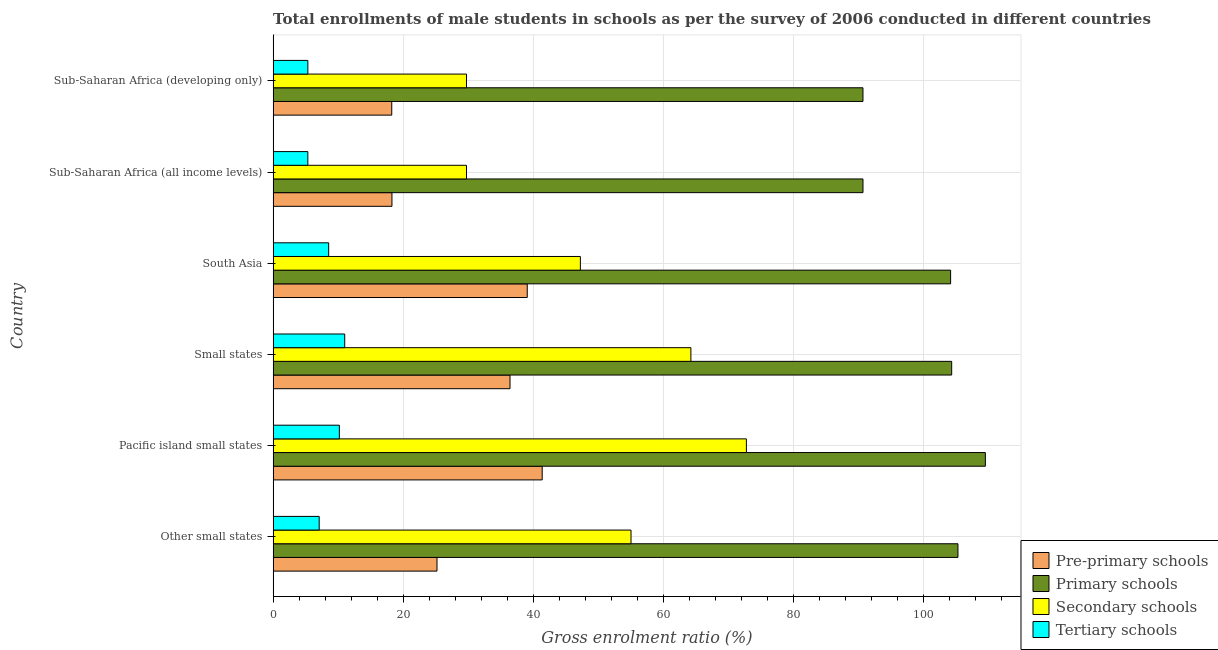How many different coloured bars are there?
Provide a succinct answer. 4. Are the number of bars per tick equal to the number of legend labels?
Your answer should be very brief. Yes. How many bars are there on the 1st tick from the top?
Provide a succinct answer. 4. What is the label of the 1st group of bars from the top?
Make the answer very short. Sub-Saharan Africa (developing only). What is the gross enrolment ratio(male) in pre-primary schools in South Asia?
Your response must be concise. 39.09. Across all countries, what is the maximum gross enrolment ratio(male) in secondary schools?
Make the answer very short. 72.81. Across all countries, what is the minimum gross enrolment ratio(male) in pre-primary schools?
Your answer should be compact. 18.25. In which country was the gross enrolment ratio(male) in pre-primary schools maximum?
Keep it short and to the point. Pacific island small states. In which country was the gross enrolment ratio(male) in pre-primary schools minimum?
Keep it short and to the point. Sub-Saharan Africa (developing only). What is the total gross enrolment ratio(male) in primary schools in the graph?
Your response must be concise. 605. What is the difference between the gross enrolment ratio(male) in secondary schools in Other small states and that in Pacific island small states?
Your response must be concise. -17.75. What is the difference between the gross enrolment ratio(male) in pre-primary schools in Small states and the gross enrolment ratio(male) in secondary schools in Sub-Saharan Africa (developing only)?
Offer a very short reply. 6.7. What is the average gross enrolment ratio(male) in secondary schools per country?
Your answer should be compact. 49.81. What is the difference between the gross enrolment ratio(male) in secondary schools and gross enrolment ratio(male) in pre-primary schools in Sub-Saharan Africa (all income levels)?
Keep it short and to the point. 11.47. In how many countries, is the gross enrolment ratio(male) in tertiary schools greater than 28 %?
Your answer should be very brief. 0. What is the ratio of the gross enrolment ratio(male) in secondary schools in South Asia to that in Sub-Saharan Africa (developing only)?
Give a very brief answer. 1.59. Is the gross enrolment ratio(male) in secondary schools in Other small states less than that in South Asia?
Your answer should be very brief. No. What is the difference between the highest and the second highest gross enrolment ratio(male) in secondary schools?
Provide a short and direct response. 8.54. What is the difference between the highest and the lowest gross enrolment ratio(male) in primary schools?
Ensure brevity in your answer.  18.83. In how many countries, is the gross enrolment ratio(male) in pre-primary schools greater than the average gross enrolment ratio(male) in pre-primary schools taken over all countries?
Keep it short and to the point. 3. Is the sum of the gross enrolment ratio(male) in primary schools in Sub-Saharan Africa (all income levels) and Sub-Saharan Africa (developing only) greater than the maximum gross enrolment ratio(male) in tertiary schools across all countries?
Provide a short and direct response. Yes. What does the 2nd bar from the top in South Asia represents?
Ensure brevity in your answer.  Secondary schools. What does the 3rd bar from the bottom in South Asia represents?
Offer a very short reply. Secondary schools. Is it the case that in every country, the sum of the gross enrolment ratio(male) in pre-primary schools and gross enrolment ratio(male) in primary schools is greater than the gross enrolment ratio(male) in secondary schools?
Offer a very short reply. Yes. Are all the bars in the graph horizontal?
Provide a short and direct response. Yes. How many countries are there in the graph?
Offer a terse response. 6. Are the values on the major ticks of X-axis written in scientific E-notation?
Offer a very short reply. No. Does the graph contain grids?
Make the answer very short. Yes. Where does the legend appear in the graph?
Your response must be concise. Bottom right. How many legend labels are there?
Your answer should be very brief. 4. How are the legend labels stacked?
Your response must be concise. Vertical. What is the title of the graph?
Offer a very short reply. Total enrollments of male students in schools as per the survey of 2006 conducted in different countries. Does "Trade" appear as one of the legend labels in the graph?
Give a very brief answer. No. What is the label or title of the X-axis?
Your answer should be compact. Gross enrolment ratio (%). What is the label or title of the Y-axis?
Keep it short and to the point. Country. What is the Gross enrolment ratio (%) in Pre-primary schools in Other small states?
Your answer should be very brief. 25.21. What is the Gross enrolment ratio (%) in Primary schools in Other small states?
Ensure brevity in your answer.  105.35. What is the Gross enrolment ratio (%) in Secondary schools in Other small states?
Offer a terse response. 55.06. What is the Gross enrolment ratio (%) in Tertiary schools in Other small states?
Your response must be concise. 7.09. What is the Gross enrolment ratio (%) in Pre-primary schools in Pacific island small states?
Your answer should be very brief. 41.39. What is the Gross enrolment ratio (%) in Primary schools in Pacific island small states?
Your answer should be compact. 109.57. What is the Gross enrolment ratio (%) of Secondary schools in Pacific island small states?
Your response must be concise. 72.81. What is the Gross enrolment ratio (%) of Tertiary schools in Pacific island small states?
Ensure brevity in your answer.  10.19. What is the Gross enrolment ratio (%) in Pre-primary schools in Small states?
Your answer should be very brief. 36.44. What is the Gross enrolment ratio (%) of Primary schools in Small states?
Offer a terse response. 104.39. What is the Gross enrolment ratio (%) of Secondary schools in Small states?
Your response must be concise. 64.27. What is the Gross enrolment ratio (%) of Tertiary schools in Small states?
Give a very brief answer. 11.01. What is the Gross enrolment ratio (%) of Pre-primary schools in South Asia?
Ensure brevity in your answer.  39.09. What is the Gross enrolment ratio (%) in Primary schools in South Asia?
Make the answer very short. 104.22. What is the Gross enrolment ratio (%) of Secondary schools in South Asia?
Keep it short and to the point. 47.26. What is the Gross enrolment ratio (%) of Tertiary schools in South Asia?
Ensure brevity in your answer.  8.55. What is the Gross enrolment ratio (%) of Pre-primary schools in Sub-Saharan Africa (all income levels)?
Your answer should be compact. 18.28. What is the Gross enrolment ratio (%) of Primary schools in Sub-Saharan Africa (all income levels)?
Offer a very short reply. 90.74. What is the Gross enrolment ratio (%) in Secondary schools in Sub-Saharan Africa (all income levels)?
Make the answer very short. 29.75. What is the Gross enrolment ratio (%) of Tertiary schools in Sub-Saharan Africa (all income levels)?
Make the answer very short. 5.34. What is the Gross enrolment ratio (%) in Pre-primary schools in Sub-Saharan Africa (developing only)?
Your answer should be very brief. 18.25. What is the Gross enrolment ratio (%) in Primary schools in Sub-Saharan Africa (developing only)?
Offer a very short reply. 90.74. What is the Gross enrolment ratio (%) in Secondary schools in Sub-Saharan Africa (developing only)?
Provide a succinct answer. 29.75. What is the Gross enrolment ratio (%) in Tertiary schools in Sub-Saharan Africa (developing only)?
Offer a very short reply. 5.34. Across all countries, what is the maximum Gross enrolment ratio (%) in Pre-primary schools?
Your response must be concise. 41.39. Across all countries, what is the maximum Gross enrolment ratio (%) in Primary schools?
Ensure brevity in your answer.  109.57. Across all countries, what is the maximum Gross enrolment ratio (%) in Secondary schools?
Your response must be concise. 72.81. Across all countries, what is the maximum Gross enrolment ratio (%) in Tertiary schools?
Keep it short and to the point. 11.01. Across all countries, what is the minimum Gross enrolment ratio (%) of Pre-primary schools?
Give a very brief answer. 18.25. Across all countries, what is the minimum Gross enrolment ratio (%) in Primary schools?
Provide a succinct answer. 90.74. Across all countries, what is the minimum Gross enrolment ratio (%) in Secondary schools?
Ensure brevity in your answer.  29.75. Across all countries, what is the minimum Gross enrolment ratio (%) of Tertiary schools?
Your answer should be compact. 5.34. What is the total Gross enrolment ratio (%) in Pre-primary schools in the graph?
Provide a short and direct response. 178.66. What is the total Gross enrolment ratio (%) of Primary schools in the graph?
Your answer should be compact. 605. What is the total Gross enrolment ratio (%) in Secondary schools in the graph?
Offer a terse response. 298.89. What is the total Gross enrolment ratio (%) in Tertiary schools in the graph?
Ensure brevity in your answer.  47.52. What is the difference between the Gross enrolment ratio (%) in Pre-primary schools in Other small states and that in Pacific island small states?
Provide a short and direct response. -16.18. What is the difference between the Gross enrolment ratio (%) of Primary schools in Other small states and that in Pacific island small states?
Your response must be concise. -4.22. What is the difference between the Gross enrolment ratio (%) of Secondary schools in Other small states and that in Pacific island small states?
Make the answer very short. -17.75. What is the difference between the Gross enrolment ratio (%) in Tertiary schools in Other small states and that in Pacific island small states?
Make the answer very short. -3.1. What is the difference between the Gross enrolment ratio (%) of Pre-primary schools in Other small states and that in Small states?
Your answer should be very brief. -11.23. What is the difference between the Gross enrolment ratio (%) of Secondary schools in Other small states and that in Small states?
Your response must be concise. -9.21. What is the difference between the Gross enrolment ratio (%) of Tertiary schools in Other small states and that in Small states?
Your response must be concise. -3.93. What is the difference between the Gross enrolment ratio (%) of Pre-primary schools in Other small states and that in South Asia?
Your answer should be very brief. -13.88. What is the difference between the Gross enrolment ratio (%) in Primary schools in Other small states and that in South Asia?
Offer a terse response. 1.13. What is the difference between the Gross enrolment ratio (%) of Secondary schools in Other small states and that in South Asia?
Ensure brevity in your answer.  7.79. What is the difference between the Gross enrolment ratio (%) of Tertiary schools in Other small states and that in South Asia?
Provide a succinct answer. -1.46. What is the difference between the Gross enrolment ratio (%) in Pre-primary schools in Other small states and that in Sub-Saharan Africa (all income levels)?
Make the answer very short. 6.93. What is the difference between the Gross enrolment ratio (%) in Primary schools in Other small states and that in Sub-Saharan Africa (all income levels)?
Give a very brief answer. 14.61. What is the difference between the Gross enrolment ratio (%) of Secondary schools in Other small states and that in Sub-Saharan Africa (all income levels)?
Your answer should be very brief. 25.31. What is the difference between the Gross enrolment ratio (%) of Tertiary schools in Other small states and that in Sub-Saharan Africa (all income levels)?
Your answer should be very brief. 1.75. What is the difference between the Gross enrolment ratio (%) in Pre-primary schools in Other small states and that in Sub-Saharan Africa (developing only)?
Your answer should be very brief. 6.96. What is the difference between the Gross enrolment ratio (%) of Primary schools in Other small states and that in Sub-Saharan Africa (developing only)?
Your answer should be compact. 14.61. What is the difference between the Gross enrolment ratio (%) in Secondary schools in Other small states and that in Sub-Saharan Africa (developing only)?
Your answer should be compact. 25.31. What is the difference between the Gross enrolment ratio (%) in Tertiary schools in Other small states and that in Sub-Saharan Africa (developing only)?
Provide a short and direct response. 1.74. What is the difference between the Gross enrolment ratio (%) of Pre-primary schools in Pacific island small states and that in Small states?
Make the answer very short. 4.95. What is the difference between the Gross enrolment ratio (%) of Primary schools in Pacific island small states and that in Small states?
Provide a short and direct response. 5.18. What is the difference between the Gross enrolment ratio (%) of Secondary schools in Pacific island small states and that in Small states?
Offer a very short reply. 8.54. What is the difference between the Gross enrolment ratio (%) in Tertiary schools in Pacific island small states and that in Small states?
Your answer should be very brief. -0.83. What is the difference between the Gross enrolment ratio (%) in Pre-primary schools in Pacific island small states and that in South Asia?
Ensure brevity in your answer.  2.3. What is the difference between the Gross enrolment ratio (%) of Primary schools in Pacific island small states and that in South Asia?
Give a very brief answer. 5.35. What is the difference between the Gross enrolment ratio (%) of Secondary schools in Pacific island small states and that in South Asia?
Ensure brevity in your answer.  25.54. What is the difference between the Gross enrolment ratio (%) of Tertiary schools in Pacific island small states and that in South Asia?
Keep it short and to the point. 1.64. What is the difference between the Gross enrolment ratio (%) in Pre-primary schools in Pacific island small states and that in Sub-Saharan Africa (all income levels)?
Offer a very short reply. 23.11. What is the difference between the Gross enrolment ratio (%) in Primary schools in Pacific island small states and that in Sub-Saharan Africa (all income levels)?
Provide a short and direct response. 18.83. What is the difference between the Gross enrolment ratio (%) of Secondary schools in Pacific island small states and that in Sub-Saharan Africa (all income levels)?
Provide a succinct answer. 43.06. What is the difference between the Gross enrolment ratio (%) in Tertiary schools in Pacific island small states and that in Sub-Saharan Africa (all income levels)?
Keep it short and to the point. 4.85. What is the difference between the Gross enrolment ratio (%) of Pre-primary schools in Pacific island small states and that in Sub-Saharan Africa (developing only)?
Provide a succinct answer. 23.14. What is the difference between the Gross enrolment ratio (%) of Primary schools in Pacific island small states and that in Sub-Saharan Africa (developing only)?
Provide a short and direct response. 18.83. What is the difference between the Gross enrolment ratio (%) in Secondary schools in Pacific island small states and that in Sub-Saharan Africa (developing only)?
Give a very brief answer. 43.06. What is the difference between the Gross enrolment ratio (%) of Tertiary schools in Pacific island small states and that in Sub-Saharan Africa (developing only)?
Make the answer very short. 4.84. What is the difference between the Gross enrolment ratio (%) in Pre-primary schools in Small states and that in South Asia?
Provide a short and direct response. -2.65. What is the difference between the Gross enrolment ratio (%) in Primary schools in Small states and that in South Asia?
Ensure brevity in your answer.  0.16. What is the difference between the Gross enrolment ratio (%) of Secondary schools in Small states and that in South Asia?
Your answer should be very brief. 17. What is the difference between the Gross enrolment ratio (%) of Tertiary schools in Small states and that in South Asia?
Offer a very short reply. 2.47. What is the difference between the Gross enrolment ratio (%) of Pre-primary schools in Small states and that in Sub-Saharan Africa (all income levels)?
Offer a very short reply. 18.16. What is the difference between the Gross enrolment ratio (%) of Primary schools in Small states and that in Sub-Saharan Africa (all income levels)?
Provide a short and direct response. 13.65. What is the difference between the Gross enrolment ratio (%) of Secondary schools in Small states and that in Sub-Saharan Africa (all income levels)?
Offer a terse response. 34.52. What is the difference between the Gross enrolment ratio (%) of Tertiary schools in Small states and that in Sub-Saharan Africa (all income levels)?
Ensure brevity in your answer.  5.67. What is the difference between the Gross enrolment ratio (%) of Pre-primary schools in Small states and that in Sub-Saharan Africa (developing only)?
Give a very brief answer. 18.2. What is the difference between the Gross enrolment ratio (%) of Primary schools in Small states and that in Sub-Saharan Africa (developing only)?
Offer a very short reply. 13.65. What is the difference between the Gross enrolment ratio (%) in Secondary schools in Small states and that in Sub-Saharan Africa (developing only)?
Provide a short and direct response. 34.52. What is the difference between the Gross enrolment ratio (%) of Tertiary schools in Small states and that in Sub-Saharan Africa (developing only)?
Provide a succinct answer. 5.67. What is the difference between the Gross enrolment ratio (%) of Pre-primary schools in South Asia and that in Sub-Saharan Africa (all income levels)?
Your response must be concise. 20.81. What is the difference between the Gross enrolment ratio (%) in Primary schools in South Asia and that in Sub-Saharan Africa (all income levels)?
Make the answer very short. 13.48. What is the difference between the Gross enrolment ratio (%) of Secondary schools in South Asia and that in Sub-Saharan Africa (all income levels)?
Keep it short and to the point. 17.52. What is the difference between the Gross enrolment ratio (%) in Tertiary schools in South Asia and that in Sub-Saharan Africa (all income levels)?
Ensure brevity in your answer.  3.2. What is the difference between the Gross enrolment ratio (%) of Pre-primary schools in South Asia and that in Sub-Saharan Africa (developing only)?
Provide a short and direct response. 20.85. What is the difference between the Gross enrolment ratio (%) of Primary schools in South Asia and that in Sub-Saharan Africa (developing only)?
Keep it short and to the point. 13.48. What is the difference between the Gross enrolment ratio (%) of Secondary schools in South Asia and that in Sub-Saharan Africa (developing only)?
Give a very brief answer. 17.52. What is the difference between the Gross enrolment ratio (%) in Tertiary schools in South Asia and that in Sub-Saharan Africa (developing only)?
Make the answer very short. 3.2. What is the difference between the Gross enrolment ratio (%) in Pre-primary schools in Sub-Saharan Africa (all income levels) and that in Sub-Saharan Africa (developing only)?
Provide a short and direct response. 0.03. What is the difference between the Gross enrolment ratio (%) of Primary schools in Sub-Saharan Africa (all income levels) and that in Sub-Saharan Africa (developing only)?
Keep it short and to the point. 0. What is the difference between the Gross enrolment ratio (%) in Secondary schools in Sub-Saharan Africa (all income levels) and that in Sub-Saharan Africa (developing only)?
Offer a terse response. -0. What is the difference between the Gross enrolment ratio (%) of Tertiary schools in Sub-Saharan Africa (all income levels) and that in Sub-Saharan Africa (developing only)?
Offer a very short reply. -0. What is the difference between the Gross enrolment ratio (%) of Pre-primary schools in Other small states and the Gross enrolment ratio (%) of Primary schools in Pacific island small states?
Give a very brief answer. -84.36. What is the difference between the Gross enrolment ratio (%) of Pre-primary schools in Other small states and the Gross enrolment ratio (%) of Secondary schools in Pacific island small states?
Provide a succinct answer. -47.6. What is the difference between the Gross enrolment ratio (%) of Pre-primary schools in Other small states and the Gross enrolment ratio (%) of Tertiary schools in Pacific island small states?
Provide a succinct answer. 15.02. What is the difference between the Gross enrolment ratio (%) of Primary schools in Other small states and the Gross enrolment ratio (%) of Secondary schools in Pacific island small states?
Your answer should be very brief. 32.54. What is the difference between the Gross enrolment ratio (%) in Primary schools in Other small states and the Gross enrolment ratio (%) in Tertiary schools in Pacific island small states?
Make the answer very short. 95.16. What is the difference between the Gross enrolment ratio (%) in Secondary schools in Other small states and the Gross enrolment ratio (%) in Tertiary schools in Pacific island small states?
Provide a short and direct response. 44.87. What is the difference between the Gross enrolment ratio (%) of Pre-primary schools in Other small states and the Gross enrolment ratio (%) of Primary schools in Small states?
Ensure brevity in your answer.  -79.18. What is the difference between the Gross enrolment ratio (%) in Pre-primary schools in Other small states and the Gross enrolment ratio (%) in Secondary schools in Small states?
Offer a very short reply. -39.06. What is the difference between the Gross enrolment ratio (%) in Pre-primary schools in Other small states and the Gross enrolment ratio (%) in Tertiary schools in Small states?
Give a very brief answer. 14.2. What is the difference between the Gross enrolment ratio (%) in Primary schools in Other small states and the Gross enrolment ratio (%) in Secondary schools in Small states?
Provide a succinct answer. 41.08. What is the difference between the Gross enrolment ratio (%) in Primary schools in Other small states and the Gross enrolment ratio (%) in Tertiary schools in Small states?
Give a very brief answer. 94.34. What is the difference between the Gross enrolment ratio (%) of Secondary schools in Other small states and the Gross enrolment ratio (%) of Tertiary schools in Small states?
Your answer should be compact. 44.04. What is the difference between the Gross enrolment ratio (%) in Pre-primary schools in Other small states and the Gross enrolment ratio (%) in Primary schools in South Asia?
Give a very brief answer. -79.01. What is the difference between the Gross enrolment ratio (%) in Pre-primary schools in Other small states and the Gross enrolment ratio (%) in Secondary schools in South Asia?
Provide a short and direct response. -22.06. What is the difference between the Gross enrolment ratio (%) in Pre-primary schools in Other small states and the Gross enrolment ratio (%) in Tertiary schools in South Asia?
Ensure brevity in your answer.  16.66. What is the difference between the Gross enrolment ratio (%) of Primary schools in Other small states and the Gross enrolment ratio (%) of Secondary schools in South Asia?
Provide a succinct answer. 58.09. What is the difference between the Gross enrolment ratio (%) in Primary schools in Other small states and the Gross enrolment ratio (%) in Tertiary schools in South Asia?
Provide a succinct answer. 96.8. What is the difference between the Gross enrolment ratio (%) in Secondary schools in Other small states and the Gross enrolment ratio (%) in Tertiary schools in South Asia?
Ensure brevity in your answer.  46.51. What is the difference between the Gross enrolment ratio (%) in Pre-primary schools in Other small states and the Gross enrolment ratio (%) in Primary schools in Sub-Saharan Africa (all income levels)?
Give a very brief answer. -65.53. What is the difference between the Gross enrolment ratio (%) of Pre-primary schools in Other small states and the Gross enrolment ratio (%) of Secondary schools in Sub-Saharan Africa (all income levels)?
Your response must be concise. -4.54. What is the difference between the Gross enrolment ratio (%) of Pre-primary schools in Other small states and the Gross enrolment ratio (%) of Tertiary schools in Sub-Saharan Africa (all income levels)?
Offer a terse response. 19.87. What is the difference between the Gross enrolment ratio (%) of Primary schools in Other small states and the Gross enrolment ratio (%) of Secondary schools in Sub-Saharan Africa (all income levels)?
Give a very brief answer. 75.6. What is the difference between the Gross enrolment ratio (%) in Primary schools in Other small states and the Gross enrolment ratio (%) in Tertiary schools in Sub-Saharan Africa (all income levels)?
Make the answer very short. 100.01. What is the difference between the Gross enrolment ratio (%) of Secondary schools in Other small states and the Gross enrolment ratio (%) of Tertiary schools in Sub-Saharan Africa (all income levels)?
Offer a terse response. 49.72. What is the difference between the Gross enrolment ratio (%) in Pre-primary schools in Other small states and the Gross enrolment ratio (%) in Primary schools in Sub-Saharan Africa (developing only)?
Your response must be concise. -65.53. What is the difference between the Gross enrolment ratio (%) in Pre-primary schools in Other small states and the Gross enrolment ratio (%) in Secondary schools in Sub-Saharan Africa (developing only)?
Offer a very short reply. -4.54. What is the difference between the Gross enrolment ratio (%) of Pre-primary schools in Other small states and the Gross enrolment ratio (%) of Tertiary schools in Sub-Saharan Africa (developing only)?
Make the answer very short. 19.86. What is the difference between the Gross enrolment ratio (%) of Primary schools in Other small states and the Gross enrolment ratio (%) of Secondary schools in Sub-Saharan Africa (developing only)?
Give a very brief answer. 75.6. What is the difference between the Gross enrolment ratio (%) in Primary schools in Other small states and the Gross enrolment ratio (%) in Tertiary schools in Sub-Saharan Africa (developing only)?
Your answer should be compact. 100.01. What is the difference between the Gross enrolment ratio (%) of Secondary schools in Other small states and the Gross enrolment ratio (%) of Tertiary schools in Sub-Saharan Africa (developing only)?
Give a very brief answer. 49.71. What is the difference between the Gross enrolment ratio (%) in Pre-primary schools in Pacific island small states and the Gross enrolment ratio (%) in Primary schools in Small states?
Your answer should be very brief. -62.99. What is the difference between the Gross enrolment ratio (%) of Pre-primary schools in Pacific island small states and the Gross enrolment ratio (%) of Secondary schools in Small states?
Your response must be concise. -22.87. What is the difference between the Gross enrolment ratio (%) in Pre-primary schools in Pacific island small states and the Gross enrolment ratio (%) in Tertiary schools in Small states?
Make the answer very short. 30.38. What is the difference between the Gross enrolment ratio (%) of Primary schools in Pacific island small states and the Gross enrolment ratio (%) of Secondary schools in Small states?
Your answer should be very brief. 45.3. What is the difference between the Gross enrolment ratio (%) of Primary schools in Pacific island small states and the Gross enrolment ratio (%) of Tertiary schools in Small states?
Give a very brief answer. 98.55. What is the difference between the Gross enrolment ratio (%) of Secondary schools in Pacific island small states and the Gross enrolment ratio (%) of Tertiary schools in Small states?
Offer a terse response. 61.79. What is the difference between the Gross enrolment ratio (%) in Pre-primary schools in Pacific island small states and the Gross enrolment ratio (%) in Primary schools in South Asia?
Your response must be concise. -62.83. What is the difference between the Gross enrolment ratio (%) in Pre-primary schools in Pacific island small states and the Gross enrolment ratio (%) in Secondary schools in South Asia?
Offer a very short reply. -5.87. What is the difference between the Gross enrolment ratio (%) of Pre-primary schools in Pacific island small states and the Gross enrolment ratio (%) of Tertiary schools in South Asia?
Offer a terse response. 32.85. What is the difference between the Gross enrolment ratio (%) of Primary schools in Pacific island small states and the Gross enrolment ratio (%) of Secondary schools in South Asia?
Your response must be concise. 62.3. What is the difference between the Gross enrolment ratio (%) of Primary schools in Pacific island small states and the Gross enrolment ratio (%) of Tertiary schools in South Asia?
Your answer should be compact. 101.02. What is the difference between the Gross enrolment ratio (%) of Secondary schools in Pacific island small states and the Gross enrolment ratio (%) of Tertiary schools in South Asia?
Keep it short and to the point. 64.26. What is the difference between the Gross enrolment ratio (%) of Pre-primary schools in Pacific island small states and the Gross enrolment ratio (%) of Primary schools in Sub-Saharan Africa (all income levels)?
Offer a terse response. -49.35. What is the difference between the Gross enrolment ratio (%) of Pre-primary schools in Pacific island small states and the Gross enrolment ratio (%) of Secondary schools in Sub-Saharan Africa (all income levels)?
Ensure brevity in your answer.  11.65. What is the difference between the Gross enrolment ratio (%) of Pre-primary schools in Pacific island small states and the Gross enrolment ratio (%) of Tertiary schools in Sub-Saharan Africa (all income levels)?
Your response must be concise. 36.05. What is the difference between the Gross enrolment ratio (%) of Primary schools in Pacific island small states and the Gross enrolment ratio (%) of Secondary schools in Sub-Saharan Africa (all income levels)?
Make the answer very short. 79.82. What is the difference between the Gross enrolment ratio (%) in Primary schools in Pacific island small states and the Gross enrolment ratio (%) in Tertiary schools in Sub-Saharan Africa (all income levels)?
Keep it short and to the point. 104.22. What is the difference between the Gross enrolment ratio (%) in Secondary schools in Pacific island small states and the Gross enrolment ratio (%) in Tertiary schools in Sub-Saharan Africa (all income levels)?
Keep it short and to the point. 67.46. What is the difference between the Gross enrolment ratio (%) in Pre-primary schools in Pacific island small states and the Gross enrolment ratio (%) in Primary schools in Sub-Saharan Africa (developing only)?
Your response must be concise. -49.35. What is the difference between the Gross enrolment ratio (%) in Pre-primary schools in Pacific island small states and the Gross enrolment ratio (%) in Secondary schools in Sub-Saharan Africa (developing only)?
Keep it short and to the point. 11.64. What is the difference between the Gross enrolment ratio (%) in Pre-primary schools in Pacific island small states and the Gross enrolment ratio (%) in Tertiary schools in Sub-Saharan Africa (developing only)?
Offer a very short reply. 36.05. What is the difference between the Gross enrolment ratio (%) in Primary schools in Pacific island small states and the Gross enrolment ratio (%) in Secondary schools in Sub-Saharan Africa (developing only)?
Offer a terse response. 79.82. What is the difference between the Gross enrolment ratio (%) of Primary schools in Pacific island small states and the Gross enrolment ratio (%) of Tertiary schools in Sub-Saharan Africa (developing only)?
Keep it short and to the point. 104.22. What is the difference between the Gross enrolment ratio (%) in Secondary schools in Pacific island small states and the Gross enrolment ratio (%) in Tertiary schools in Sub-Saharan Africa (developing only)?
Your answer should be very brief. 67.46. What is the difference between the Gross enrolment ratio (%) of Pre-primary schools in Small states and the Gross enrolment ratio (%) of Primary schools in South Asia?
Provide a succinct answer. -67.78. What is the difference between the Gross enrolment ratio (%) in Pre-primary schools in Small states and the Gross enrolment ratio (%) in Secondary schools in South Asia?
Your response must be concise. -10.82. What is the difference between the Gross enrolment ratio (%) of Pre-primary schools in Small states and the Gross enrolment ratio (%) of Tertiary schools in South Asia?
Your answer should be very brief. 27.9. What is the difference between the Gross enrolment ratio (%) in Primary schools in Small states and the Gross enrolment ratio (%) in Secondary schools in South Asia?
Keep it short and to the point. 57.12. What is the difference between the Gross enrolment ratio (%) of Primary schools in Small states and the Gross enrolment ratio (%) of Tertiary schools in South Asia?
Your response must be concise. 95.84. What is the difference between the Gross enrolment ratio (%) of Secondary schools in Small states and the Gross enrolment ratio (%) of Tertiary schools in South Asia?
Provide a succinct answer. 55.72. What is the difference between the Gross enrolment ratio (%) of Pre-primary schools in Small states and the Gross enrolment ratio (%) of Primary schools in Sub-Saharan Africa (all income levels)?
Make the answer very short. -54.3. What is the difference between the Gross enrolment ratio (%) in Pre-primary schools in Small states and the Gross enrolment ratio (%) in Secondary schools in Sub-Saharan Africa (all income levels)?
Make the answer very short. 6.7. What is the difference between the Gross enrolment ratio (%) in Pre-primary schools in Small states and the Gross enrolment ratio (%) in Tertiary schools in Sub-Saharan Africa (all income levels)?
Ensure brevity in your answer.  31.1. What is the difference between the Gross enrolment ratio (%) of Primary schools in Small states and the Gross enrolment ratio (%) of Secondary schools in Sub-Saharan Africa (all income levels)?
Your answer should be very brief. 74.64. What is the difference between the Gross enrolment ratio (%) in Primary schools in Small states and the Gross enrolment ratio (%) in Tertiary schools in Sub-Saharan Africa (all income levels)?
Keep it short and to the point. 99.04. What is the difference between the Gross enrolment ratio (%) in Secondary schools in Small states and the Gross enrolment ratio (%) in Tertiary schools in Sub-Saharan Africa (all income levels)?
Keep it short and to the point. 58.93. What is the difference between the Gross enrolment ratio (%) in Pre-primary schools in Small states and the Gross enrolment ratio (%) in Primary schools in Sub-Saharan Africa (developing only)?
Offer a very short reply. -54.29. What is the difference between the Gross enrolment ratio (%) of Pre-primary schools in Small states and the Gross enrolment ratio (%) of Secondary schools in Sub-Saharan Africa (developing only)?
Your response must be concise. 6.7. What is the difference between the Gross enrolment ratio (%) in Pre-primary schools in Small states and the Gross enrolment ratio (%) in Tertiary schools in Sub-Saharan Africa (developing only)?
Give a very brief answer. 31.1. What is the difference between the Gross enrolment ratio (%) in Primary schools in Small states and the Gross enrolment ratio (%) in Secondary schools in Sub-Saharan Africa (developing only)?
Provide a short and direct response. 74.64. What is the difference between the Gross enrolment ratio (%) of Primary schools in Small states and the Gross enrolment ratio (%) of Tertiary schools in Sub-Saharan Africa (developing only)?
Offer a very short reply. 99.04. What is the difference between the Gross enrolment ratio (%) of Secondary schools in Small states and the Gross enrolment ratio (%) of Tertiary schools in Sub-Saharan Africa (developing only)?
Make the answer very short. 58.92. What is the difference between the Gross enrolment ratio (%) in Pre-primary schools in South Asia and the Gross enrolment ratio (%) in Primary schools in Sub-Saharan Africa (all income levels)?
Your answer should be compact. -51.65. What is the difference between the Gross enrolment ratio (%) in Pre-primary schools in South Asia and the Gross enrolment ratio (%) in Secondary schools in Sub-Saharan Africa (all income levels)?
Your answer should be compact. 9.35. What is the difference between the Gross enrolment ratio (%) in Pre-primary schools in South Asia and the Gross enrolment ratio (%) in Tertiary schools in Sub-Saharan Africa (all income levels)?
Give a very brief answer. 33.75. What is the difference between the Gross enrolment ratio (%) in Primary schools in South Asia and the Gross enrolment ratio (%) in Secondary schools in Sub-Saharan Africa (all income levels)?
Make the answer very short. 74.47. What is the difference between the Gross enrolment ratio (%) in Primary schools in South Asia and the Gross enrolment ratio (%) in Tertiary schools in Sub-Saharan Africa (all income levels)?
Keep it short and to the point. 98.88. What is the difference between the Gross enrolment ratio (%) in Secondary schools in South Asia and the Gross enrolment ratio (%) in Tertiary schools in Sub-Saharan Africa (all income levels)?
Offer a very short reply. 41.92. What is the difference between the Gross enrolment ratio (%) of Pre-primary schools in South Asia and the Gross enrolment ratio (%) of Primary schools in Sub-Saharan Africa (developing only)?
Provide a short and direct response. -51.64. What is the difference between the Gross enrolment ratio (%) of Pre-primary schools in South Asia and the Gross enrolment ratio (%) of Secondary schools in Sub-Saharan Africa (developing only)?
Your answer should be very brief. 9.35. What is the difference between the Gross enrolment ratio (%) in Pre-primary schools in South Asia and the Gross enrolment ratio (%) in Tertiary schools in Sub-Saharan Africa (developing only)?
Your answer should be very brief. 33.75. What is the difference between the Gross enrolment ratio (%) in Primary schools in South Asia and the Gross enrolment ratio (%) in Secondary schools in Sub-Saharan Africa (developing only)?
Offer a very short reply. 74.47. What is the difference between the Gross enrolment ratio (%) of Primary schools in South Asia and the Gross enrolment ratio (%) of Tertiary schools in Sub-Saharan Africa (developing only)?
Make the answer very short. 98.88. What is the difference between the Gross enrolment ratio (%) in Secondary schools in South Asia and the Gross enrolment ratio (%) in Tertiary schools in Sub-Saharan Africa (developing only)?
Your answer should be compact. 41.92. What is the difference between the Gross enrolment ratio (%) of Pre-primary schools in Sub-Saharan Africa (all income levels) and the Gross enrolment ratio (%) of Primary schools in Sub-Saharan Africa (developing only)?
Provide a short and direct response. -72.46. What is the difference between the Gross enrolment ratio (%) of Pre-primary schools in Sub-Saharan Africa (all income levels) and the Gross enrolment ratio (%) of Secondary schools in Sub-Saharan Africa (developing only)?
Your answer should be compact. -11.47. What is the difference between the Gross enrolment ratio (%) in Pre-primary schools in Sub-Saharan Africa (all income levels) and the Gross enrolment ratio (%) in Tertiary schools in Sub-Saharan Africa (developing only)?
Your answer should be compact. 12.94. What is the difference between the Gross enrolment ratio (%) of Primary schools in Sub-Saharan Africa (all income levels) and the Gross enrolment ratio (%) of Secondary schools in Sub-Saharan Africa (developing only)?
Give a very brief answer. 60.99. What is the difference between the Gross enrolment ratio (%) in Primary schools in Sub-Saharan Africa (all income levels) and the Gross enrolment ratio (%) in Tertiary schools in Sub-Saharan Africa (developing only)?
Your answer should be compact. 85.4. What is the difference between the Gross enrolment ratio (%) in Secondary schools in Sub-Saharan Africa (all income levels) and the Gross enrolment ratio (%) in Tertiary schools in Sub-Saharan Africa (developing only)?
Keep it short and to the point. 24.4. What is the average Gross enrolment ratio (%) in Pre-primary schools per country?
Provide a short and direct response. 29.78. What is the average Gross enrolment ratio (%) in Primary schools per country?
Ensure brevity in your answer.  100.83. What is the average Gross enrolment ratio (%) of Secondary schools per country?
Make the answer very short. 49.81. What is the average Gross enrolment ratio (%) in Tertiary schools per country?
Provide a succinct answer. 7.92. What is the difference between the Gross enrolment ratio (%) in Pre-primary schools and Gross enrolment ratio (%) in Primary schools in Other small states?
Your answer should be compact. -80.14. What is the difference between the Gross enrolment ratio (%) of Pre-primary schools and Gross enrolment ratio (%) of Secondary schools in Other small states?
Offer a very short reply. -29.85. What is the difference between the Gross enrolment ratio (%) in Pre-primary schools and Gross enrolment ratio (%) in Tertiary schools in Other small states?
Your answer should be very brief. 18.12. What is the difference between the Gross enrolment ratio (%) of Primary schools and Gross enrolment ratio (%) of Secondary schools in Other small states?
Your answer should be compact. 50.29. What is the difference between the Gross enrolment ratio (%) of Primary schools and Gross enrolment ratio (%) of Tertiary schools in Other small states?
Ensure brevity in your answer.  98.26. What is the difference between the Gross enrolment ratio (%) of Secondary schools and Gross enrolment ratio (%) of Tertiary schools in Other small states?
Your answer should be very brief. 47.97. What is the difference between the Gross enrolment ratio (%) of Pre-primary schools and Gross enrolment ratio (%) of Primary schools in Pacific island small states?
Ensure brevity in your answer.  -68.17. What is the difference between the Gross enrolment ratio (%) in Pre-primary schools and Gross enrolment ratio (%) in Secondary schools in Pacific island small states?
Give a very brief answer. -31.41. What is the difference between the Gross enrolment ratio (%) of Pre-primary schools and Gross enrolment ratio (%) of Tertiary schools in Pacific island small states?
Make the answer very short. 31.21. What is the difference between the Gross enrolment ratio (%) in Primary schools and Gross enrolment ratio (%) in Secondary schools in Pacific island small states?
Provide a short and direct response. 36.76. What is the difference between the Gross enrolment ratio (%) in Primary schools and Gross enrolment ratio (%) in Tertiary schools in Pacific island small states?
Your response must be concise. 99.38. What is the difference between the Gross enrolment ratio (%) in Secondary schools and Gross enrolment ratio (%) in Tertiary schools in Pacific island small states?
Your response must be concise. 62.62. What is the difference between the Gross enrolment ratio (%) in Pre-primary schools and Gross enrolment ratio (%) in Primary schools in Small states?
Provide a short and direct response. -67.94. What is the difference between the Gross enrolment ratio (%) of Pre-primary schools and Gross enrolment ratio (%) of Secondary schools in Small states?
Provide a short and direct response. -27.82. What is the difference between the Gross enrolment ratio (%) in Pre-primary schools and Gross enrolment ratio (%) in Tertiary schools in Small states?
Provide a succinct answer. 25.43. What is the difference between the Gross enrolment ratio (%) of Primary schools and Gross enrolment ratio (%) of Secondary schools in Small states?
Give a very brief answer. 40.12. What is the difference between the Gross enrolment ratio (%) of Primary schools and Gross enrolment ratio (%) of Tertiary schools in Small states?
Your answer should be compact. 93.37. What is the difference between the Gross enrolment ratio (%) of Secondary schools and Gross enrolment ratio (%) of Tertiary schools in Small states?
Offer a terse response. 53.25. What is the difference between the Gross enrolment ratio (%) in Pre-primary schools and Gross enrolment ratio (%) in Primary schools in South Asia?
Your answer should be very brief. -65.13. What is the difference between the Gross enrolment ratio (%) in Pre-primary schools and Gross enrolment ratio (%) in Secondary schools in South Asia?
Your answer should be compact. -8.17. What is the difference between the Gross enrolment ratio (%) of Pre-primary schools and Gross enrolment ratio (%) of Tertiary schools in South Asia?
Provide a succinct answer. 30.55. What is the difference between the Gross enrolment ratio (%) in Primary schools and Gross enrolment ratio (%) in Secondary schools in South Asia?
Provide a succinct answer. 56.96. What is the difference between the Gross enrolment ratio (%) of Primary schools and Gross enrolment ratio (%) of Tertiary schools in South Asia?
Offer a very short reply. 95.68. What is the difference between the Gross enrolment ratio (%) of Secondary schools and Gross enrolment ratio (%) of Tertiary schools in South Asia?
Provide a short and direct response. 38.72. What is the difference between the Gross enrolment ratio (%) in Pre-primary schools and Gross enrolment ratio (%) in Primary schools in Sub-Saharan Africa (all income levels)?
Offer a terse response. -72.46. What is the difference between the Gross enrolment ratio (%) of Pre-primary schools and Gross enrolment ratio (%) of Secondary schools in Sub-Saharan Africa (all income levels)?
Provide a succinct answer. -11.47. What is the difference between the Gross enrolment ratio (%) in Pre-primary schools and Gross enrolment ratio (%) in Tertiary schools in Sub-Saharan Africa (all income levels)?
Your answer should be very brief. 12.94. What is the difference between the Gross enrolment ratio (%) of Primary schools and Gross enrolment ratio (%) of Secondary schools in Sub-Saharan Africa (all income levels)?
Your answer should be very brief. 60.99. What is the difference between the Gross enrolment ratio (%) in Primary schools and Gross enrolment ratio (%) in Tertiary schools in Sub-Saharan Africa (all income levels)?
Your answer should be very brief. 85.4. What is the difference between the Gross enrolment ratio (%) of Secondary schools and Gross enrolment ratio (%) of Tertiary schools in Sub-Saharan Africa (all income levels)?
Your answer should be compact. 24.41. What is the difference between the Gross enrolment ratio (%) of Pre-primary schools and Gross enrolment ratio (%) of Primary schools in Sub-Saharan Africa (developing only)?
Your response must be concise. -72.49. What is the difference between the Gross enrolment ratio (%) in Pre-primary schools and Gross enrolment ratio (%) in Secondary schools in Sub-Saharan Africa (developing only)?
Keep it short and to the point. -11.5. What is the difference between the Gross enrolment ratio (%) in Pre-primary schools and Gross enrolment ratio (%) in Tertiary schools in Sub-Saharan Africa (developing only)?
Give a very brief answer. 12.9. What is the difference between the Gross enrolment ratio (%) in Primary schools and Gross enrolment ratio (%) in Secondary schools in Sub-Saharan Africa (developing only)?
Offer a terse response. 60.99. What is the difference between the Gross enrolment ratio (%) of Primary schools and Gross enrolment ratio (%) of Tertiary schools in Sub-Saharan Africa (developing only)?
Your answer should be very brief. 85.39. What is the difference between the Gross enrolment ratio (%) in Secondary schools and Gross enrolment ratio (%) in Tertiary schools in Sub-Saharan Africa (developing only)?
Your answer should be compact. 24.4. What is the ratio of the Gross enrolment ratio (%) in Pre-primary schools in Other small states to that in Pacific island small states?
Provide a succinct answer. 0.61. What is the ratio of the Gross enrolment ratio (%) in Primary schools in Other small states to that in Pacific island small states?
Give a very brief answer. 0.96. What is the ratio of the Gross enrolment ratio (%) of Secondary schools in Other small states to that in Pacific island small states?
Your response must be concise. 0.76. What is the ratio of the Gross enrolment ratio (%) in Tertiary schools in Other small states to that in Pacific island small states?
Offer a terse response. 0.7. What is the ratio of the Gross enrolment ratio (%) of Pre-primary schools in Other small states to that in Small states?
Provide a succinct answer. 0.69. What is the ratio of the Gross enrolment ratio (%) in Primary schools in Other small states to that in Small states?
Your response must be concise. 1.01. What is the ratio of the Gross enrolment ratio (%) of Secondary schools in Other small states to that in Small states?
Your response must be concise. 0.86. What is the ratio of the Gross enrolment ratio (%) in Tertiary schools in Other small states to that in Small states?
Offer a very short reply. 0.64. What is the ratio of the Gross enrolment ratio (%) in Pre-primary schools in Other small states to that in South Asia?
Ensure brevity in your answer.  0.64. What is the ratio of the Gross enrolment ratio (%) in Primary schools in Other small states to that in South Asia?
Make the answer very short. 1.01. What is the ratio of the Gross enrolment ratio (%) in Secondary schools in Other small states to that in South Asia?
Your response must be concise. 1.16. What is the ratio of the Gross enrolment ratio (%) in Tertiary schools in Other small states to that in South Asia?
Keep it short and to the point. 0.83. What is the ratio of the Gross enrolment ratio (%) in Pre-primary schools in Other small states to that in Sub-Saharan Africa (all income levels)?
Your answer should be compact. 1.38. What is the ratio of the Gross enrolment ratio (%) of Primary schools in Other small states to that in Sub-Saharan Africa (all income levels)?
Provide a short and direct response. 1.16. What is the ratio of the Gross enrolment ratio (%) of Secondary schools in Other small states to that in Sub-Saharan Africa (all income levels)?
Make the answer very short. 1.85. What is the ratio of the Gross enrolment ratio (%) in Tertiary schools in Other small states to that in Sub-Saharan Africa (all income levels)?
Your answer should be very brief. 1.33. What is the ratio of the Gross enrolment ratio (%) in Pre-primary schools in Other small states to that in Sub-Saharan Africa (developing only)?
Your response must be concise. 1.38. What is the ratio of the Gross enrolment ratio (%) of Primary schools in Other small states to that in Sub-Saharan Africa (developing only)?
Your answer should be compact. 1.16. What is the ratio of the Gross enrolment ratio (%) of Secondary schools in Other small states to that in Sub-Saharan Africa (developing only)?
Your answer should be very brief. 1.85. What is the ratio of the Gross enrolment ratio (%) of Tertiary schools in Other small states to that in Sub-Saharan Africa (developing only)?
Ensure brevity in your answer.  1.33. What is the ratio of the Gross enrolment ratio (%) of Pre-primary schools in Pacific island small states to that in Small states?
Offer a terse response. 1.14. What is the ratio of the Gross enrolment ratio (%) in Primary schools in Pacific island small states to that in Small states?
Your response must be concise. 1.05. What is the ratio of the Gross enrolment ratio (%) in Secondary schools in Pacific island small states to that in Small states?
Provide a succinct answer. 1.13. What is the ratio of the Gross enrolment ratio (%) in Tertiary schools in Pacific island small states to that in Small states?
Ensure brevity in your answer.  0.92. What is the ratio of the Gross enrolment ratio (%) of Pre-primary schools in Pacific island small states to that in South Asia?
Your answer should be compact. 1.06. What is the ratio of the Gross enrolment ratio (%) in Primary schools in Pacific island small states to that in South Asia?
Your response must be concise. 1.05. What is the ratio of the Gross enrolment ratio (%) of Secondary schools in Pacific island small states to that in South Asia?
Your answer should be compact. 1.54. What is the ratio of the Gross enrolment ratio (%) in Tertiary schools in Pacific island small states to that in South Asia?
Provide a short and direct response. 1.19. What is the ratio of the Gross enrolment ratio (%) in Pre-primary schools in Pacific island small states to that in Sub-Saharan Africa (all income levels)?
Your answer should be very brief. 2.26. What is the ratio of the Gross enrolment ratio (%) in Primary schools in Pacific island small states to that in Sub-Saharan Africa (all income levels)?
Provide a short and direct response. 1.21. What is the ratio of the Gross enrolment ratio (%) of Secondary schools in Pacific island small states to that in Sub-Saharan Africa (all income levels)?
Provide a short and direct response. 2.45. What is the ratio of the Gross enrolment ratio (%) in Tertiary schools in Pacific island small states to that in Sub-Saharan Africa (all income levels)?
Ensure brevity in your answer.  1.91. What is the ratio of the Gross enrolment ratio (%) in Pre-primary schools in Pacific island small states to that in Sub-Saharan Africa (developing only)?
Offer a terse response. 2.27. What is the ratio of the Gross enrolment ratio (%) in Primary schools in Pacific island small states to that in Sub-Saharan Africa (developing only)?
Offer a very short reply. 1.21. What is the ratio of the Gross enrolment ratio (%) of Secondary schools in Pacific island small states to that in Sub-Saharan Africa (developing only)?
Keep it short and to the point. 2.45. What is the ratio of the Gross enrolment ratio (%) of Tertiary schools in Pacific island small states to that in Sub-Saharan Africa (developing only)?
Offer a very short reply. 1.91. What is the ratio of the Gross enrolment ratio (%) in Pre-primary schools in Small states to that in South Asia?
Offer a terse response. 0.93. What is the ratio of the Gross enrolment ratio (%) of Primary schools in Small states to that in South Asia?
Offer a very short reply. 1. What is the ratio of the Gross enrolment ratio (%) in Secondary schools in Small states to that in South Asia?
Your response must be concise. 1.36. What is the ratio of the Gross enrolment ratio (%) of Tertiary schools in Small states to that in South Asia?
Your response must be concise. 1.29. What is the ratio of the Gross enrolment ratio (%) in Pre-primary schools in Small states to that in Sub-Saharan Africa (all income levels)?
Your answer should be compact. 1.99. What is the ratio of the Gross enrolment ratio (%) of Primary schools in Small states to that in Sub-Saharan Africa (all income levels)?
Make the answer very short. 1.15. What is the ratio of the Gross enrolment ratio (%) of Secondary schools in Small states to that in Sub-Saharan Africa (all income levels)?
Give a very brief answer. 2.16. What is the ratio of the Gross enrolment ratio (%) of Tertiary schools in Small states to that in Sub-Saharan Africa (all income levels)?
Give a very brief answer. 2.06. What is the ratio of the Gross enrolment ratio (%) in Pre-primary schools in Small states to that in Sub-Saharan Africa (developing only)?
Your response must be concise. 2. What is the ratio of the Gross enrolment ratio (%) in Primary schools in Small states to that in Sub-Saharan Africa (developing only)?
Make the answer very short. 1.15. What is the ratio of the Gross enrolment ratio (%) of Secondary schools in Small states to that in Sub-Saharan Africa (developing only)?
Your response must be concise. 2.16. What is the ratio of the Gross enrolment ratio (%) in Tertiary schools in Small states to that in Sub-Saharan Africa (developing only)?
Your answer should be compact. 2.06. What is the ratio of the Gross enrolment ratio (%) in Pre-primary schools in South Asia to that in Sub-Saharan Africa (all income levels)?
Your answer should be very brief. 2.14. What is the ratio of the Gross enrolment ratio (%) of Primary schools in South Asia to that in Sub-Saharan Africa (all income levels)?
Provide a short and direct response. 1.15. What is the ratio of the Gross enrolment ratio (%) of Secondary schools in South Asia to that in Sub-Saharan Africa (all income levels)?
Keep it short and to the point. 1.59. What is the ratio of the Gross enrolment ratio (%) in Tertiary schools in South Asia to that in Sub-Saharan Africa (all income levels)?
Keep it short and to the point. 1.6. What is the ratio of the Gross enrolment ratio (%) of Pre-primary schools in South Asia to that in Sub-Saharan Africa (developing only)?
Offer a terse response. 2.14. What is the ratio of the Gross enrolment ratio (%) in Primary schools in South Asia to that in Sub-Saharan Africa (developing only)?
Give a very brief answer. 1.15. What is the ratio of the Gross enrolment ratio (%) of Secondary schools in South Asia to that in Sub-Saharan Africa (developing only)?
Your response must be concise. 1.59. What is the ratio of the Gross enrolment ratio (%) in Tertiary schools in South Asia to that in Sub-Saharan Africa (developing only)?
Give a very brief answer. 1.6. What is the ratio of the Gross enrolment ratio (%) of Primary schools in Sub-Saharan Africa (all income levels) to that in Sub-Saharan Africa (developing only)?
Your answer should be very brief. 1. What is the ratio of the Gross enrolment ratio (%) in Secondary schools in Sub-Saharan Africa (all income levels) to that in Sub-Saharan Africa (developing only)?
Your answer should be very brief. 1. What is the ratio of the Gross enrolment ratio (%) in Tertiary schools in Sub-Saharan Africa (all income levels) to that in Sub-Saharan Africa (developing only)?
Make the answer very short. 1. What is the difference between the highest and the second highest Gross enrolment ratio (%) in Pre-primary schools?
Make the answer very short. 2.3. What is the difference between the highest and the second highest Gross enrolment ratio (%) of Primary schools?
Your answer should be compact. 4.22. What is the difference between the highest and the second highest Gross enrolment ratio (%) in Secondary schools?
Make the answer very short. 8.54. What is the difference between the highest and the second highest Gross enrolment ratio (%) of Tertiary schools?
Offer a very short reply. 0.83. What is the difference between the highest and the lowest Gross enrolment ratio (%) of Pre-primary schools?
Give a very brief answer. 23.14. What is the difference between the highest and the lowest Gross enrolment ratio (%) of Primary schools?
Offer a terse response. 18.83. What is the difference between the highest and the lowest Gross enrolment ratio (%) in Secondary schools?
Keep it short and to the point. 43.06. What is the difference between the highest and the lowest Gross enrolment ratio (%) of Tertiary schools?
Provide a succinct answer. 5.67. 